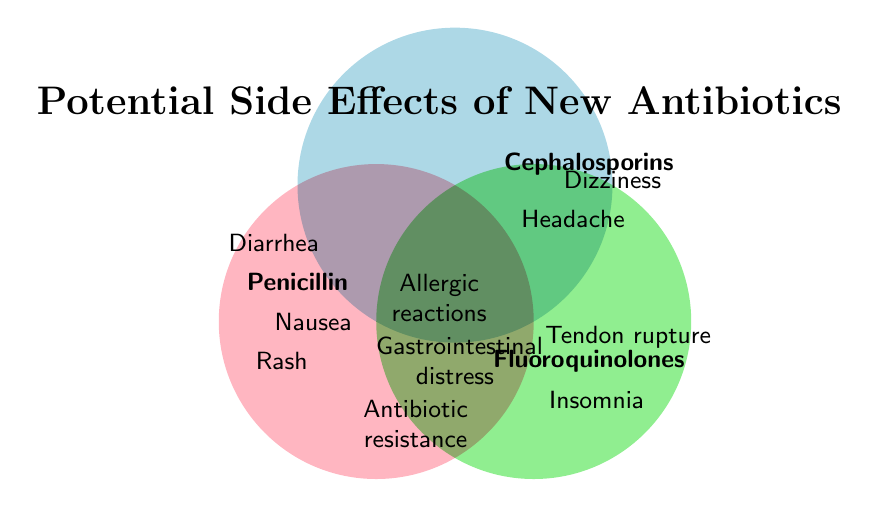Which antibiotics have "Nausea" as a potential side effect? Look at the intersection or specific sections for side effects in the Venn diagram. Nausea appears in the section for Penicillin and Fluoroquinolones.
Answer: Penicillin, Fluoroquinolones Which side effects are common to all antibiotics listed in the diagram? Review the center area where all three circles intersect. The side effects listed in this central region are common to all.
Answer: Allergic reactions, Gastrointestinal distress, Antibiotic resistance What side effect is common between Penicillin and Cephalosporins? Inspect the overlap area between the circles of Penicillin and Cephalosporins. The common side effect listed here is Rash.
Answer: Rash What unique side effects are associated with Fluoroquinolones that are not shared with Penicillin or Cephalosporins? Look at the section of the Fluoroquinolones circle that does not overlap with any other circle. These unique side effects are Tendon rupture and Insomnia.
Answer: Tendon rupture, Insomnia How many side effects are listed for Penicillin in total? Count the total number of side effects mentioned specifically in the Penicillin circle, including shared side effects in overlapping sections.
Answer: 3 Identify a side effect that is unique to Cephalosporins. View the section dedicated to Cephalosporins that does not overlap with other circles. The unique side effect is Dizziness and Headache.
Answer: Dizziness, Headache What is the title of the Venn diagram? Read the title located at the top of the diagram.
Answer: Potential Side Effects of New Antibiotics Which antibiotic has a side effect of "Diarrhea"? Find the section of the diagram specifically for Penicillin and see if Diarrhea is listed there.
Answer: Penicillin Are "Allergic reactions" associated with Fluoroquinolones? Check if "Allergic reactions" appears within the Fluoroquinolones circle. Since it is in the all circle, it is associated with Fluoroquinolones as well.
Answer: Yes Between Penicillin and Cephalosporins, which one has more unique side effects listed? Compare the number of unique side effects in the Penicillin and Cephalosporins sections. Penicillin has three (if including those shared with all), Cephalosporins have two unique (if excluding overlapping with "All").
Answer: Penicillin 